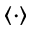<formula> <loc_0><loc_0><loc_500><loc_500>\langle \cdot \rangle</formula> 